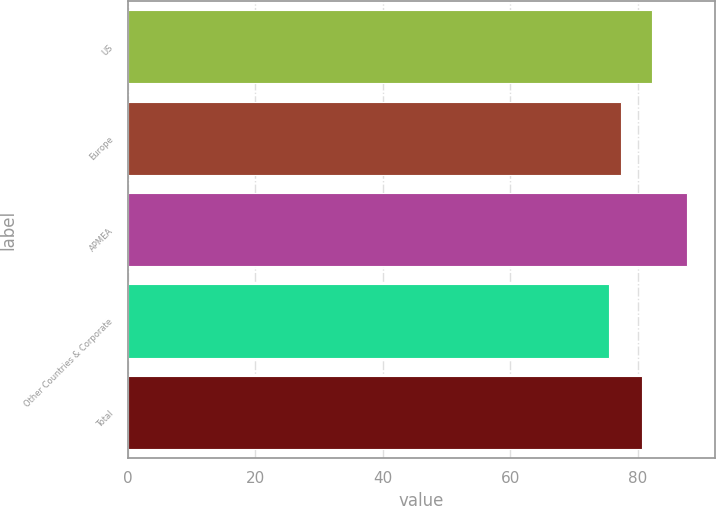Convert chart. <chart><loc_0><loc_0><loc_500><loc_500><bar_chart><fcel>US<fcel>Europe<fcel>APMEA<fcel>Other Countries & Corporate<fcel>Total<nl><fcel>82.3<fcel>77.4<fcel>87.8<fcel>75.6<fcel>80.7<nl></chart> 